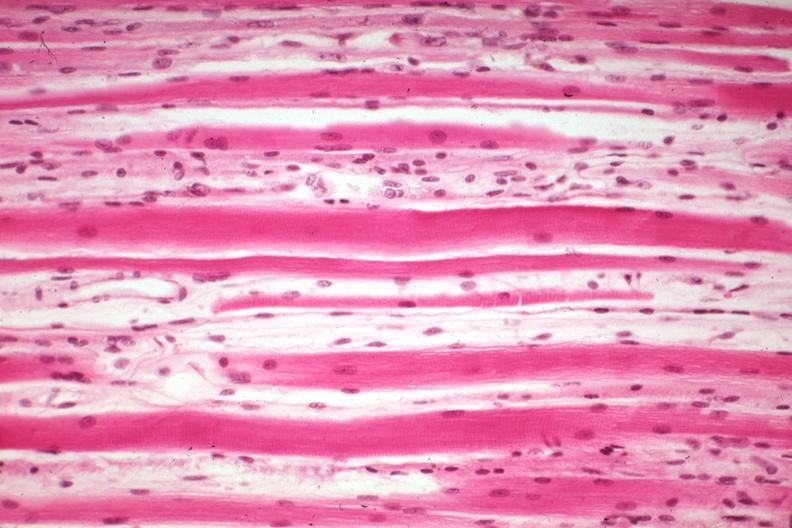s soft tissue present?
Answer the question using a single word or phrase. Yes 